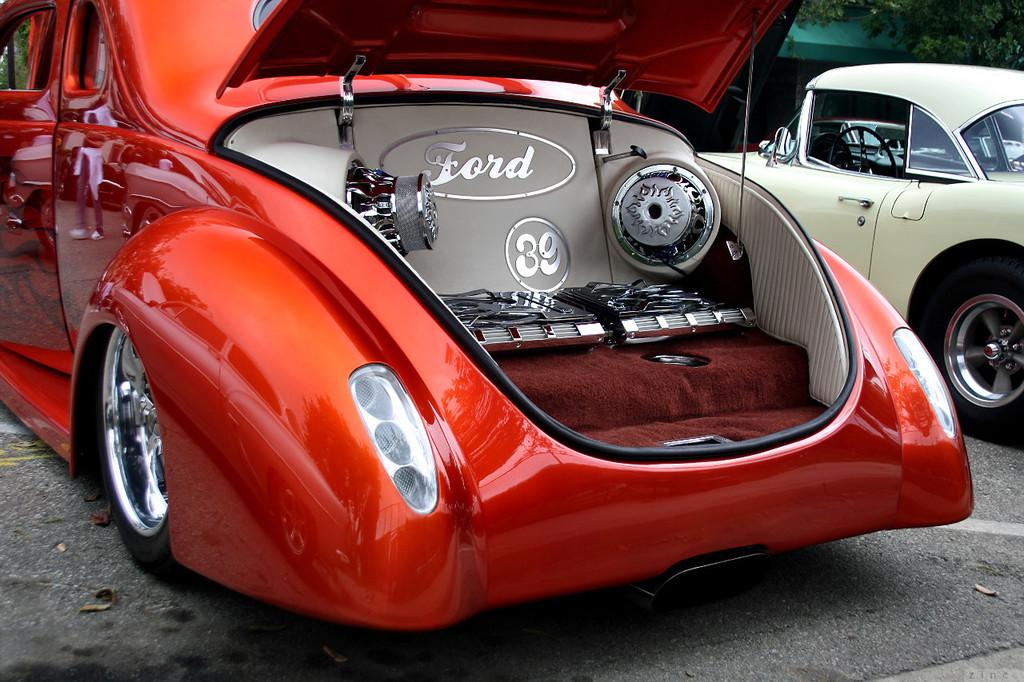<image>
Write a terse but informative summary of the picture. Red vehicle for Ford with the number 39 on it. 